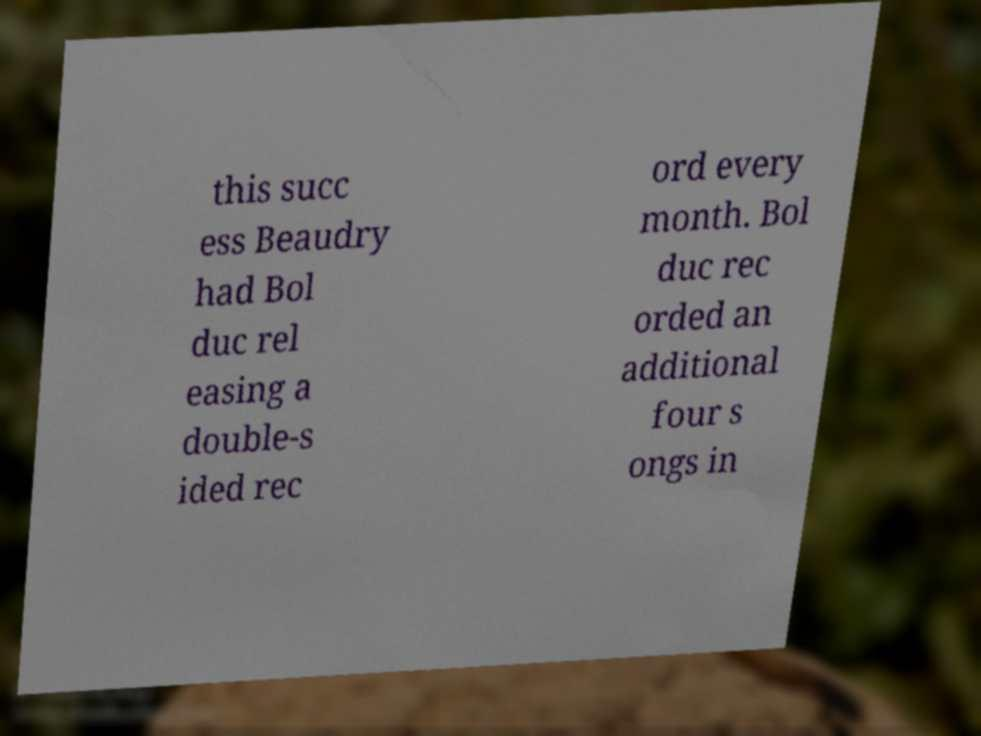For documentation purposes, I need the text within this image transcribed. Could you provide that? this succ ess Beaudry had Bol duc rel easing a double-s ided rec ord every month. Bol duc rec orded an additional four s ongs in 